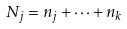<formula> <loc_0><loc_0><loc_500><loc_500>N _ { j } = n _ { j } + \cdots + n _ { k }</formula> 